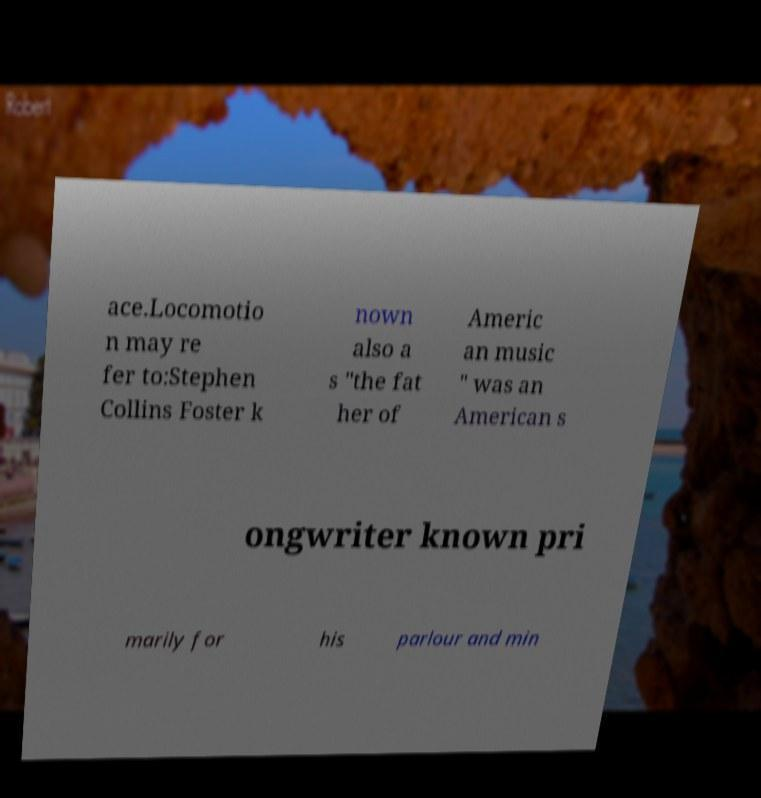I need the written content from this picture converted into text. Can you do that? ace.Locomotio n may re fer to:Stephen Collins Foster k nown also a s "the fat her of Americ an music " was an American s ongwriter known pri marily for his parlour and min 